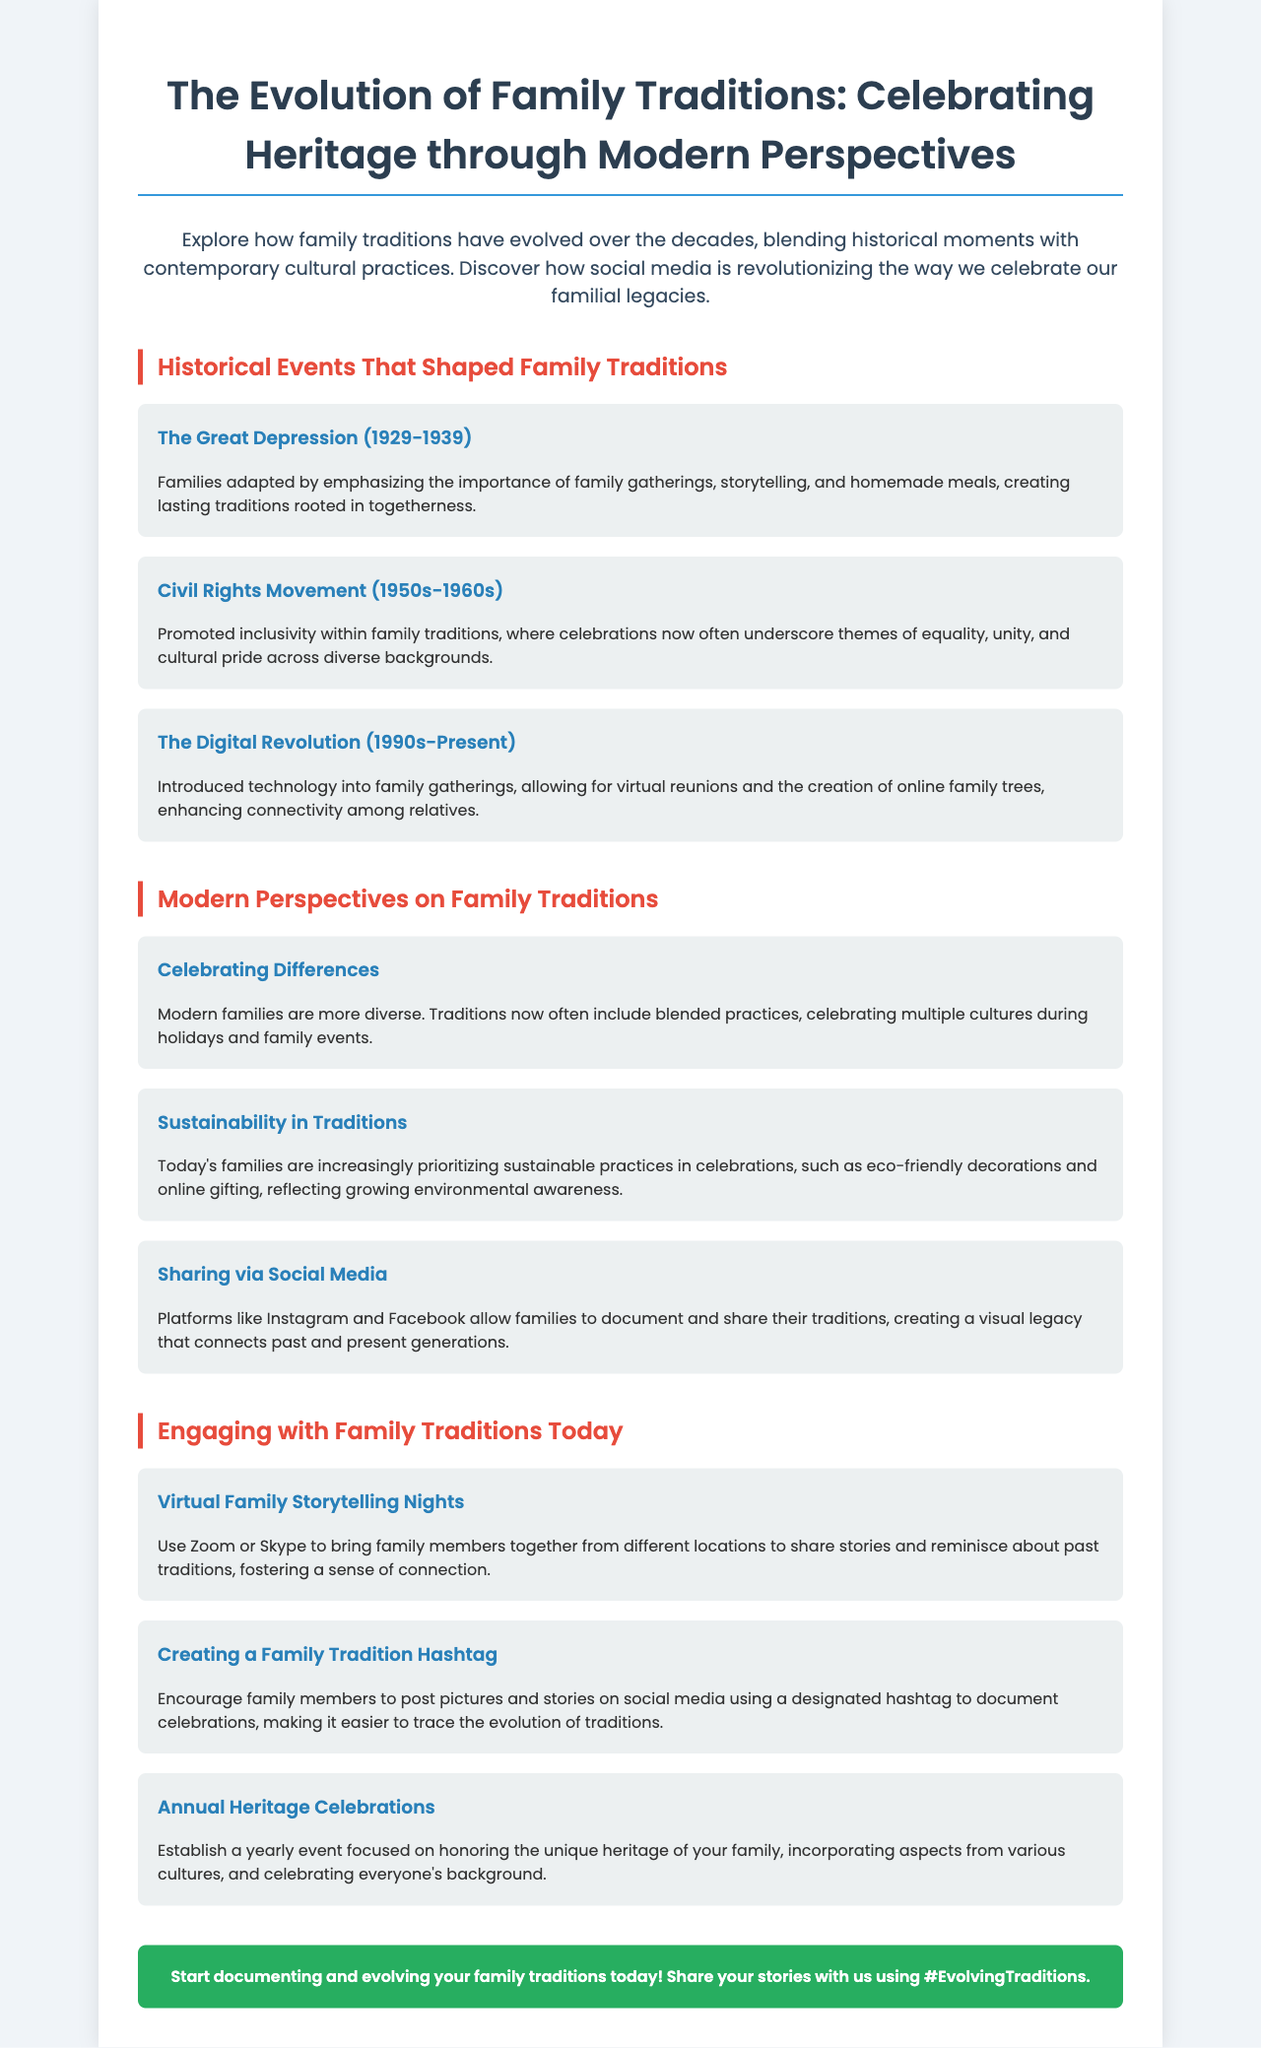What is the title of the brochure? The title is found at the top of the document.
Answer: The Evolution of Family Traditions: Celebrating Heritage through Modern Perspectives What historical event is associated with the years 1929-1939? This information can be found in the section about historical events.
Answer: The Great Depression What modern practice is highlighted that reflects growing environmental awareness? This is mentioned under modern perspectives on family traditions.
Answer: Sustainability in Traditions How many sections are in the brochure? By counting the distinct sections presented in the document.
Answer: Three What social media action is encouraged for documenting family traditions? This can be found in the last section of the document.
Answer: Creating a Family Tradition Hashtag Which movement promoted inclusivity in family traditions? This detail is specifically mentioned in relation to historical events.
Answer: Civil Rights Movement What technology is mentioned that brings family members together virtually? This is referenced in the engaging with family traditions section.
Answer: Zoom or Skype How are families sharing their traditions according to the document? This information is found in the modern perspectives section on social media.
Answer: Sharing via Social Media What is the call to action at the end of the brochure? This is the final statement encouraging reader engagement.
Answer: Start documenting and evolving your family traditions today! Share your stories with us using #EvolvingTraditions 